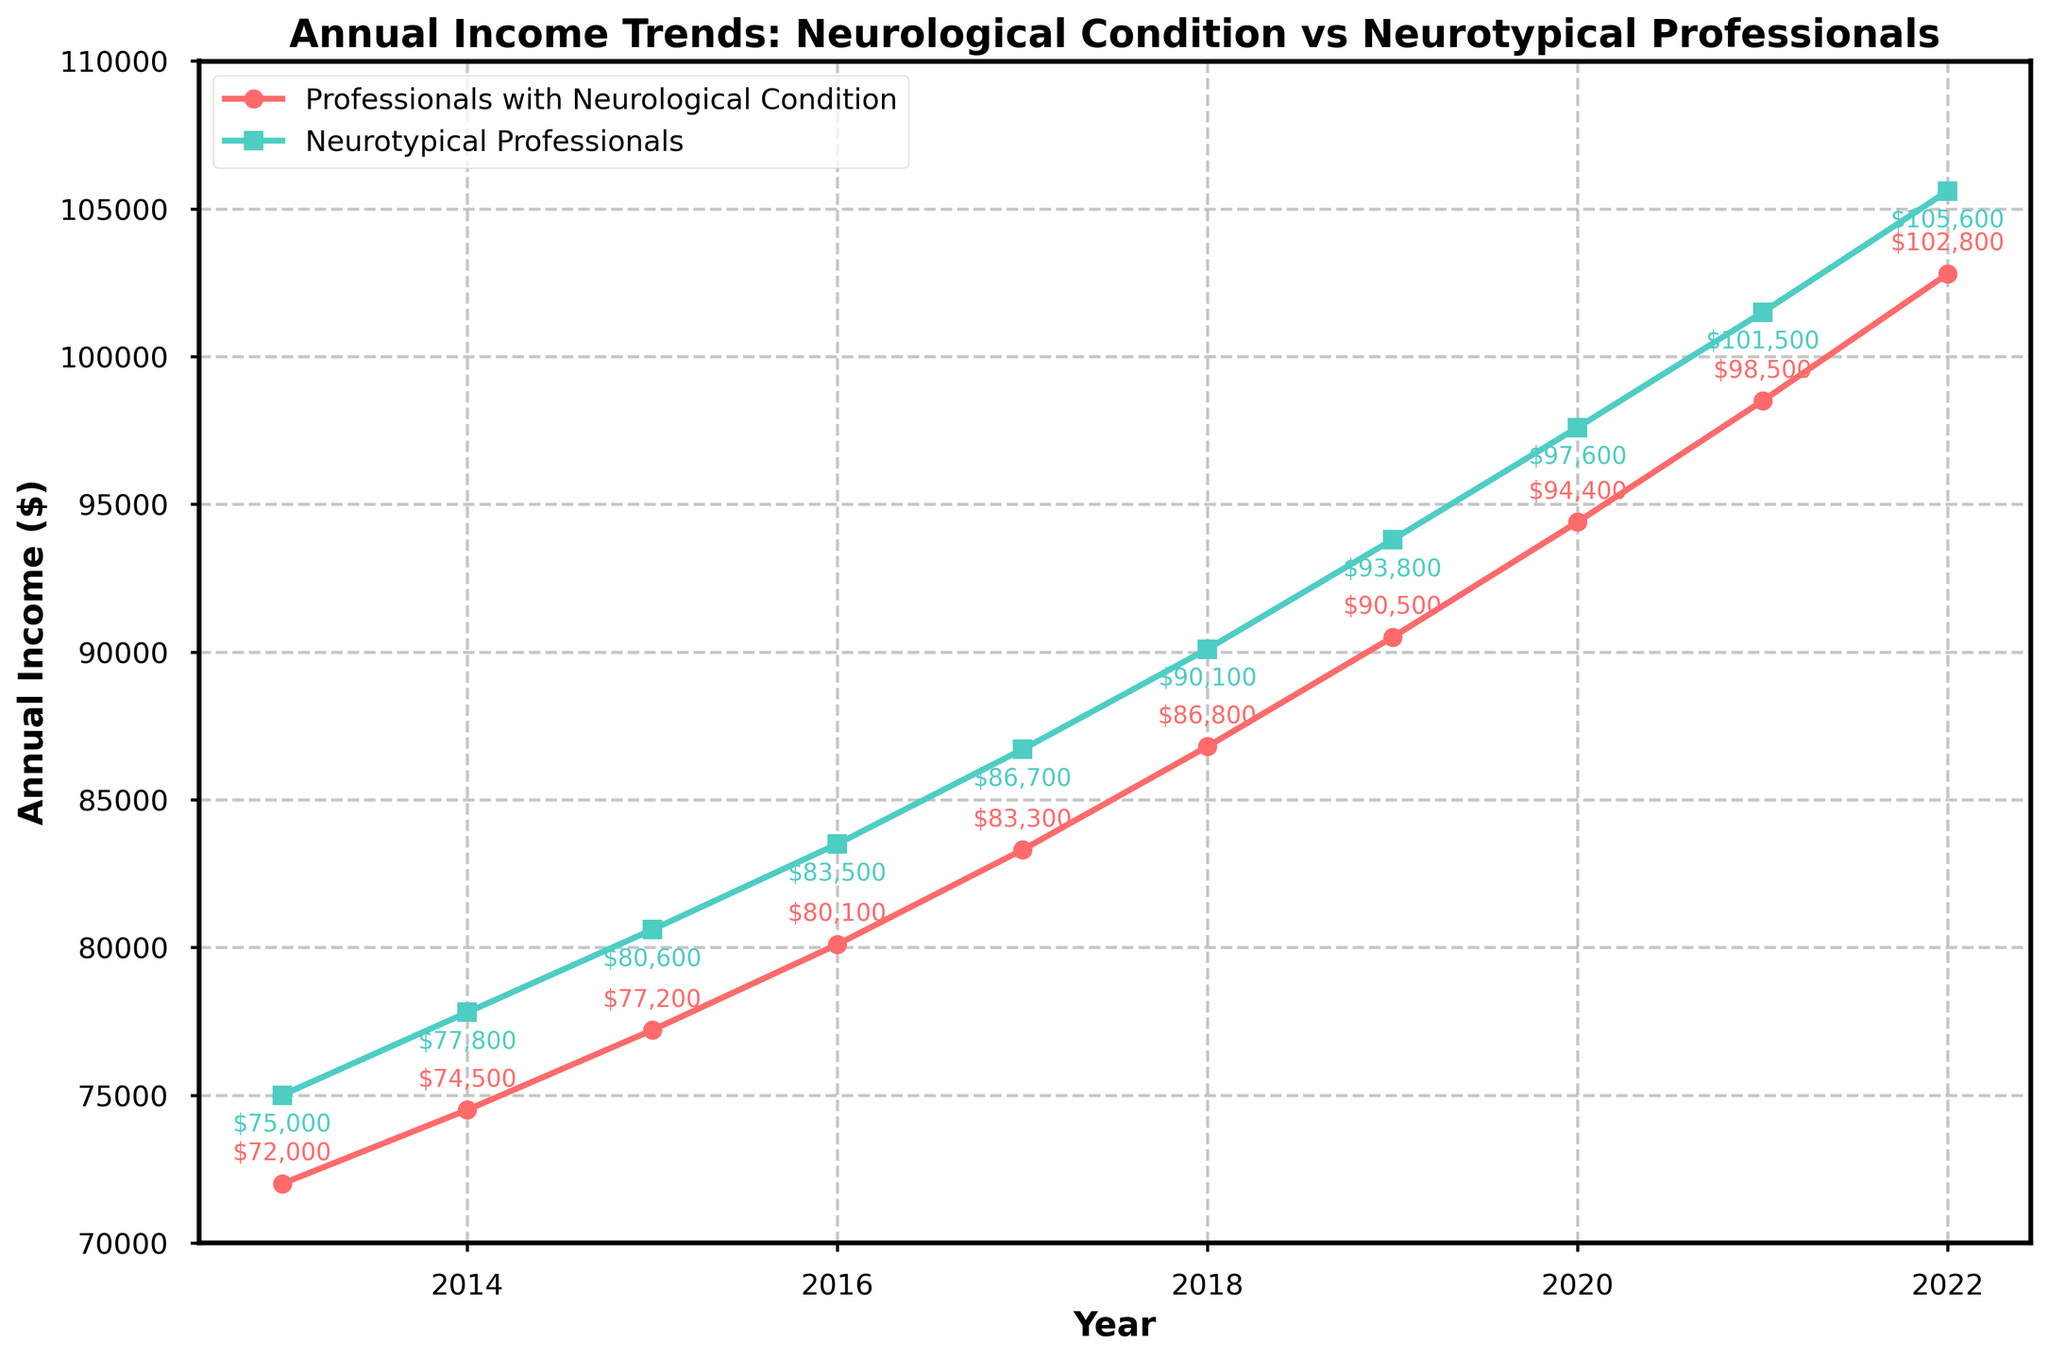What is the difference in annual income between professionals with neurological conditions and neurotypical professionals in 2022? In 2022, professionals with neurological conditions had an annual income of $102,800, while neurotypical professionals had an annual income of $105,600. The difference is $105,600 - $102,800.
Answer: $2,800 How did the income of professionals with neurological conditions change from 2013 to 2022? In 2013, the income was $72,000, and in 2022, it was $102,800. The change is $102,800 - $72,000.
Answer: $30,800 In which year did professionals with neurological conditions reach an annual income of at least $90,000? From the plot, professionals with neurological conditions reached an annual income of at least $90,000 in 2019, when their income was $90,500.
Answer: 2019 By how much did the income of neurotypical professionals increase from 2016 to 2020? In 2016, the income of neurotypical professionals was $83,500, and in 2020, it was $97,600. The increase is $97,600 - $83,500.
Answer: $14,100 On average, what was the annual income for professionals with neurological conditions over the period shown? Sum the annual incomes from 2013 to 2022 for professionals with neurological conditions: $72,000 + $74,500 + $77,200 + $80,100 + $83,300 + $86,800 + $90,500 + $94,400 + $98,500 + $102,800 = $859,100. Then, divide by the 10 years: $859,100 / 10.
Answer: $85,910 Compare the rate of income growth for both groups from 2013 to 2022. Which group had a faster growth rate? For professionals with neurological conditions: ($102,800 - $72,000) / $72,000 * 100% = 42.8%. For neurotypical professionals: ($105,600 - $75,000) / $75,000 * 100% = 40.8%. The professionals with neurological conditions had a faster growth rate.
Answer: Professionals with neurological conditions What visual colors represent the different groups in the chart? The plot uses red to represent professionals with neurological conditions and green to represent neurotypical professionals.
Answer: Red for neurological conditions, green for neurotypical Which group had a higher annual income in 2015, and by how much? In 2015, professionals with neurological conditions had an income of $77,200, while neurotypical professionals had an income of $80,600. The difference is $80,600 - $77,200.
Answer: Neurotypical professionals by $3,400 From 2013 to 2022, how many years did the income of professionals with neurological conditions increase each year without any decrease? The plot shows a consistent increase in annual income for professionals with neurological conditions every year from 2013 to 2022.
Answer: 10 years What is the annual income of neurotypical professionals in 2018? According to the plot, in 2018, the annual income of neurotypical professionals was $90,100.
Answer: $90,100 